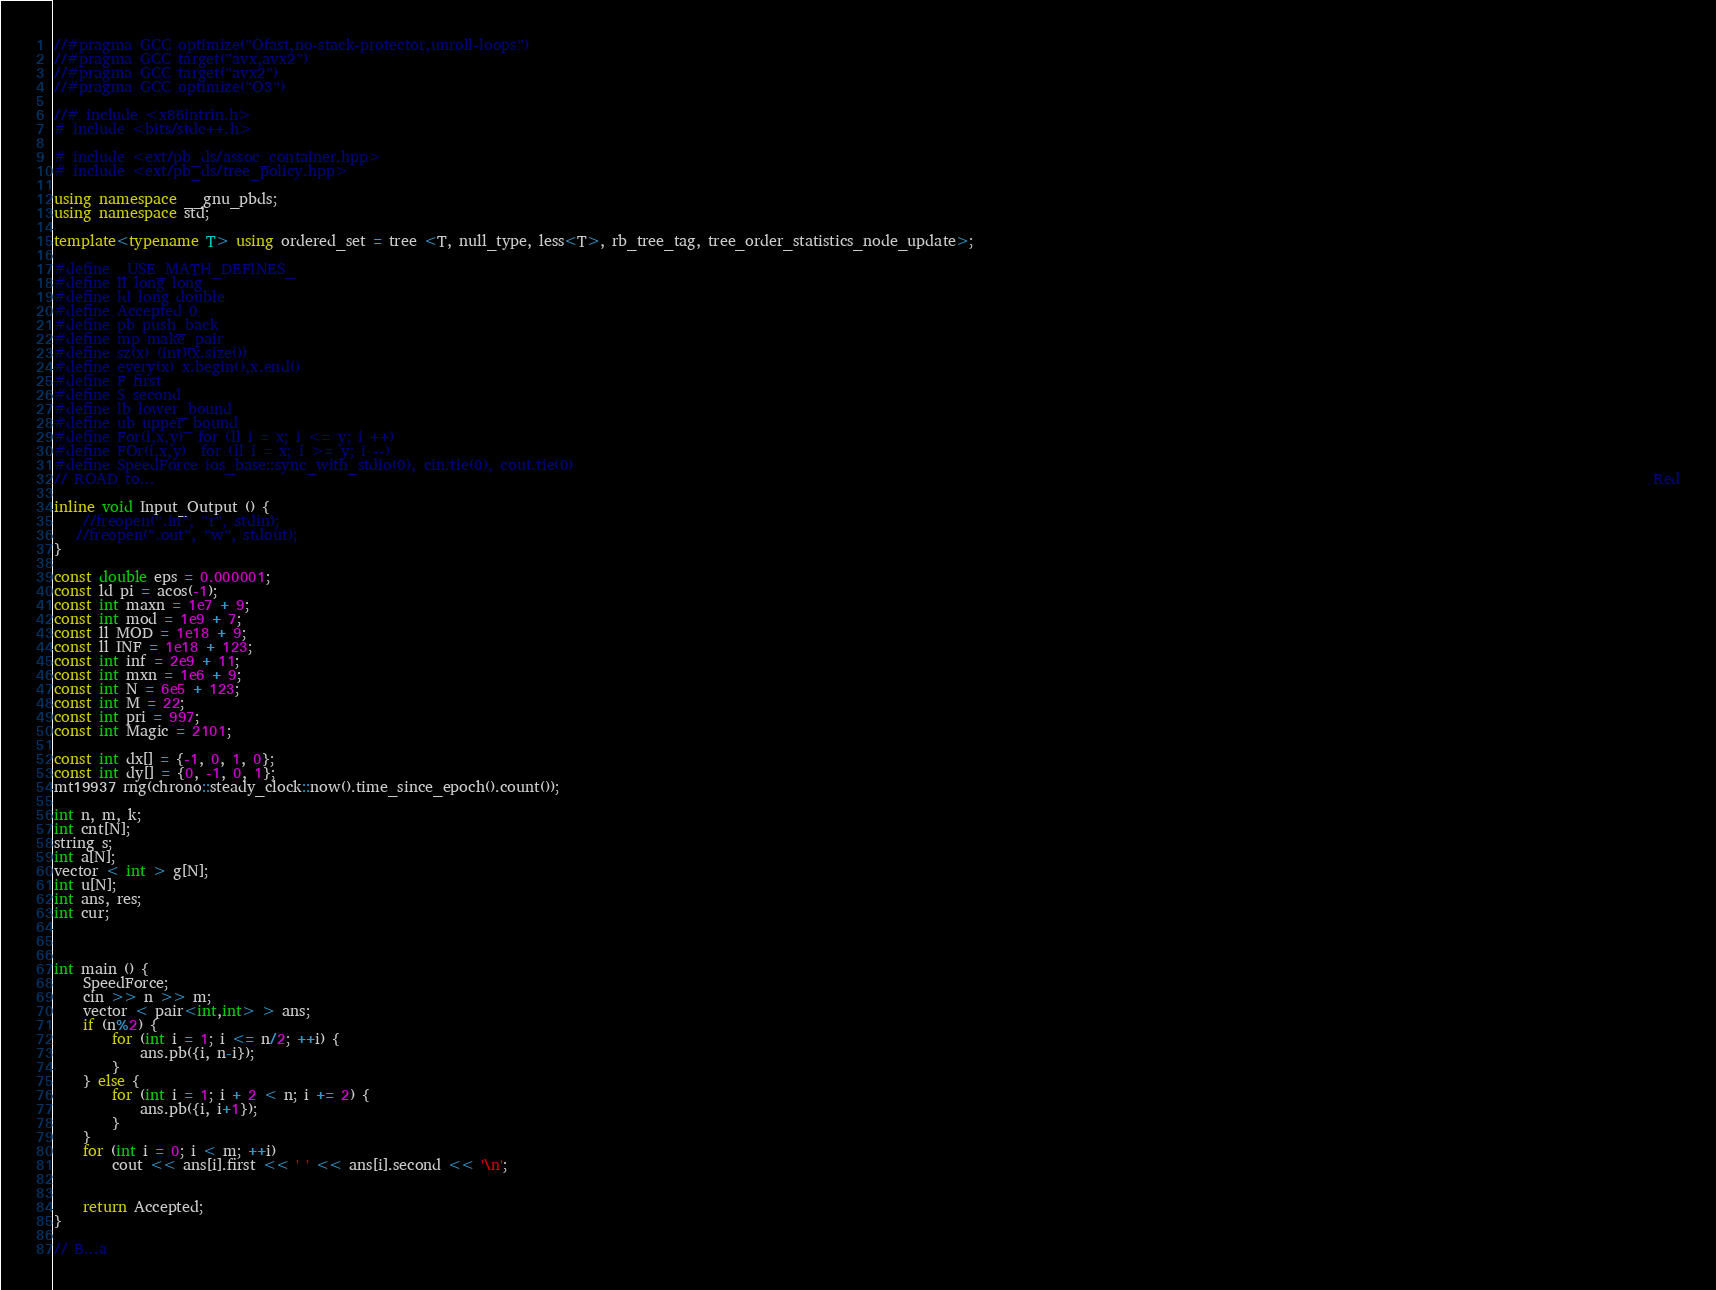Convert code to text. <code><loc_0><loc_0><loc_500><loc_500><_C++_>//#pragma GCC optimize("Ofast,no-stack-protector,unroll-loops")
//#pragma GCC target("avx,avx2")
//#pragma GCC target("avx2")
//#pragma GCC optimize("O3")

//# include <x86intrin.h>
# include <bits/stdc++.h>

# include <ext/pb_ds/assoc_container.hpp>
# include <ext/pb_ds/tree_policy.hpp>

using namespace __gnu_pbds;
using namespace std;
 
template<typename T> using ordered_set = tree <T, null_type, less<T>, rb_tree_tag, tree_order_statistics_node_update>;

#define _USE_MATH_DEFINES_
#define ll long long
#define ld long double
#define Accepted 0
#define pb push_back
#define mp make_pair
#define sz(x) (int)(x.size())
#define every(x) x.begin(),x.end()
#define F first
#define S second
#define lb lower_bound
#define ub upper_bound
#define For(i,x,y)  for (ll i = x; i <= y; i ++) 
#define FOr(i,x,y)  for (ll i = x; i >= y; i --)
#define SpeedForce ios_base::sync_with_stdio(0), cin.tie(0), cout.tie(0)
// ROAD to...                                                                                                                                                                                                                Red

inline void Input_Output () {
	//freopen(".in", "r", stdin);
   //freopen(".out", "w", stdout);
}

const double eps = 0.000001;
const ld pi = acos(-1);
const int maxn = 1e7 + 9;
const int mod = 1e9 + 7;
const ll MOD = 1e18 + 9;
const ll INF = 1e18 + 123;
const int inf = 2e9 + 11;
const int mxn = 1e6 + 9;
const int N = 6e5 + 123;                                          
const int M = 22;
const int pri = 997;
const int Magic = 2101;

const int dx[] = {-1, 0, 1, 0};
const int dy[] = {0, -1, 0, 1};
mt19937 rng(chrono::steady_clock::now().time_since_epoch().count());
 
int n, m, k;
int cnt[N];
string s;
int a[N];
vector < int > g[N];
int u[N];
int ans, res;
int cur;



int main () {
	SpeedForce;
	cin >> n >> m;
	vector < pair<int,int> > ans;
	if (n%2) {
		for (int i = 1; i <= n/2; ++i) {
			ans.pb({i, n-i});
		}
	} else {
		for (int i = 1; i + 2 < n; i += 2) {
			ans.pb({i, i+1});
		}
	}
	for (int i = 0; i < m; ++i)
		cout << ans[i].first << ' ' << ans[i].second << '\n';


	return Accepted;
}

// B...a</code> 